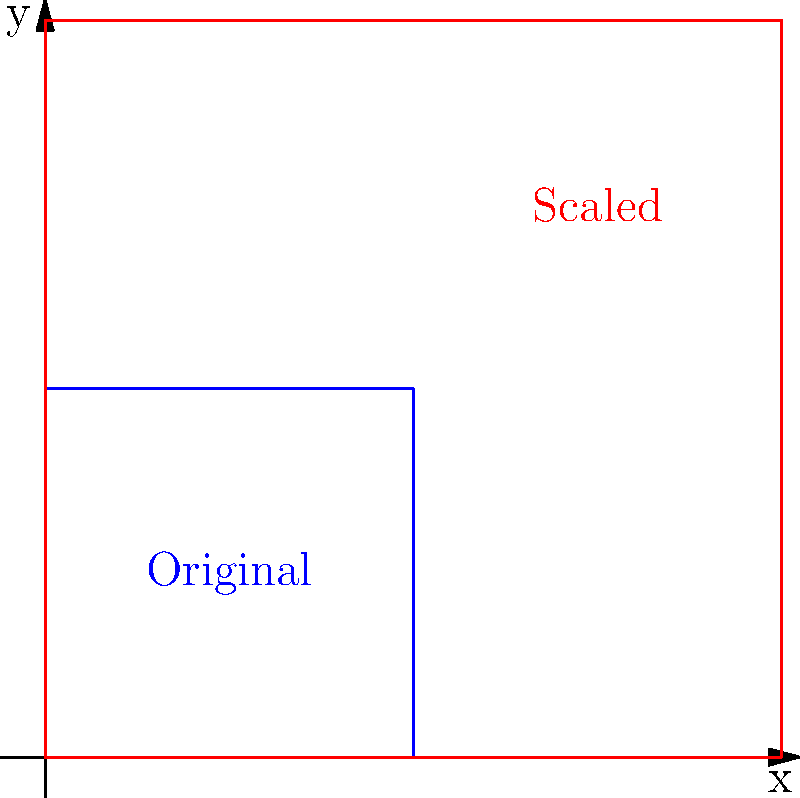In the study of insect exoskeleton growth, a junior entomologist observes that a particular species' exoskeleton undergoes uniform scaling during molting. If the original exoskeleton is represented by a square with side length 1 unit, and after molting, the new exoskeleton is represented by a square with side length 2 units, what is the scale factor of this transformation? Additionally, how does the area of the exoskeleton change after molting? To solve this problem, let's break it down into steps:

1. Determine the scale factor:
   The scale factor is the ratio of the new dimension to the original dimension.
   New side length = 2 units
   Original side length = 1 unit
   Scale factor = $\frac{\text{New side length}}{\text{Original side length}} = \frac{2}{1} = 2$

2. Calculate the change in area:
   a. Original area: $A_1 = 1^2 = 1$ square unit
   b. New area: $A_2 = 2^2 = 4$ square units
   c. To find the factor by which the area increased, divide the new area by the original area:
      $\frac{A_2}{A_1} = \frac{4}{1} = 4$

3. Relationship between scale factor and area change:
   Note that the area increase factor (4) is equal to the square of the scale factor $(2^2 = 4)$.
   This is because area scales with the square of the linear dimensions.

Therefore, the scale factor of the transformation is 2, and the area of the exoskeleton increases by a factor of 4 after molting.
Answer: Scale factor: 2; Area increase: 4-fold 